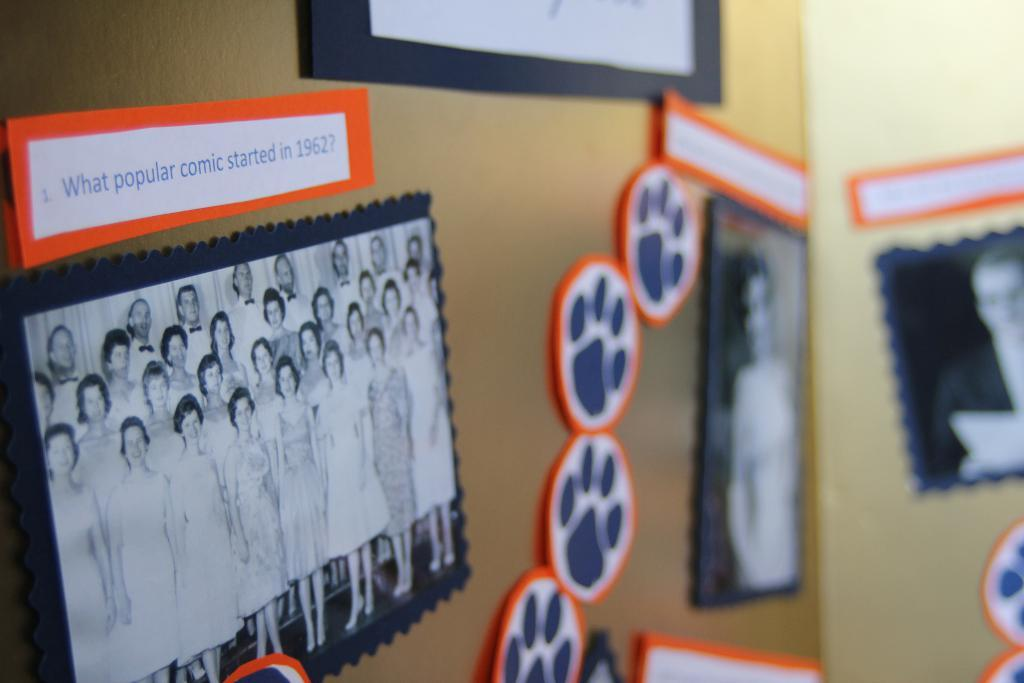What can be seen on the wall in the image? There are many photos on the wall. What additional information is provided with the photos? There are descriptions associated with the photos. What type of sign can be seen in the alley behind the wall with the photos? There is no alley or sign present in the image; it only features photos on the wall with their descriptions. 